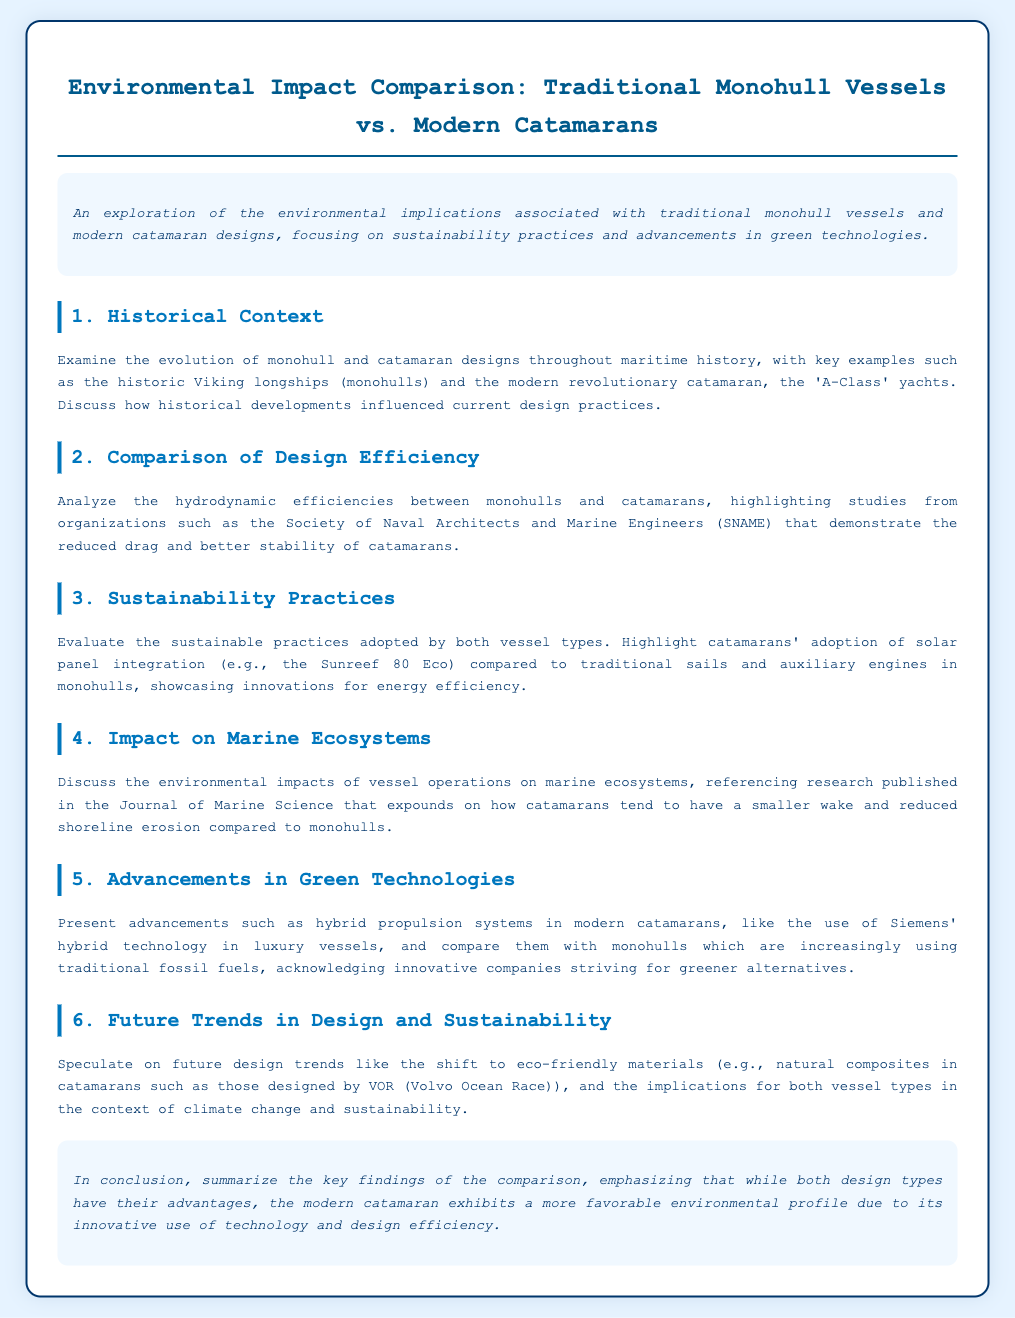What is the title of the document? The title of the document is presented prominently at the top, indicating the main focus of the content.
Answer: Environmental Impact Comparison: Traditional Monohull Vessels vs. Modern Catamarans Who are the key historical examples mentioned? The document notes significant historical vessels, providing context for the discussion on monohulls and catamarans.
Answer: Viking longships and A-Class yachts What type of solar technology is highlighted in catamarans? The document references specific sustainable practices related to energy efficiency in catamarans, in particular highlighting a specific model.
Answer: Solar panel integration What is one advantage of catamarans mentioned in terms of marine ecosystems? The document discusses the impact of vessel operations on marine environments, comparing the effects of both vessel types.
Answer: Smaller wake What advancement in propulsion systems is noted for modern catamarans? The document mentions a specific technology used in luxurious vessels to improve their environmental performance.
Answer: Hybrid propulsion systems What does the conclusion emphasize regarding catamarans? The conclusion provides a summary of findings, focusing on the overall environmental profile of different vessel types.
Answer: More favorable environmental profile What future trend in materials is speculated for catamarans? The document hints at upcoming changes in design and material choices for sustainability efforts within catamarans.
Answer: Eco-friendly materials Which organization is cited regarding design efficiencies? A specific group is mentioned that conducts studies comparing the hydrodynamic performance of vessel types in the document.
Answer: Society of Naval Architects and Marine Engineers (SNAME) 